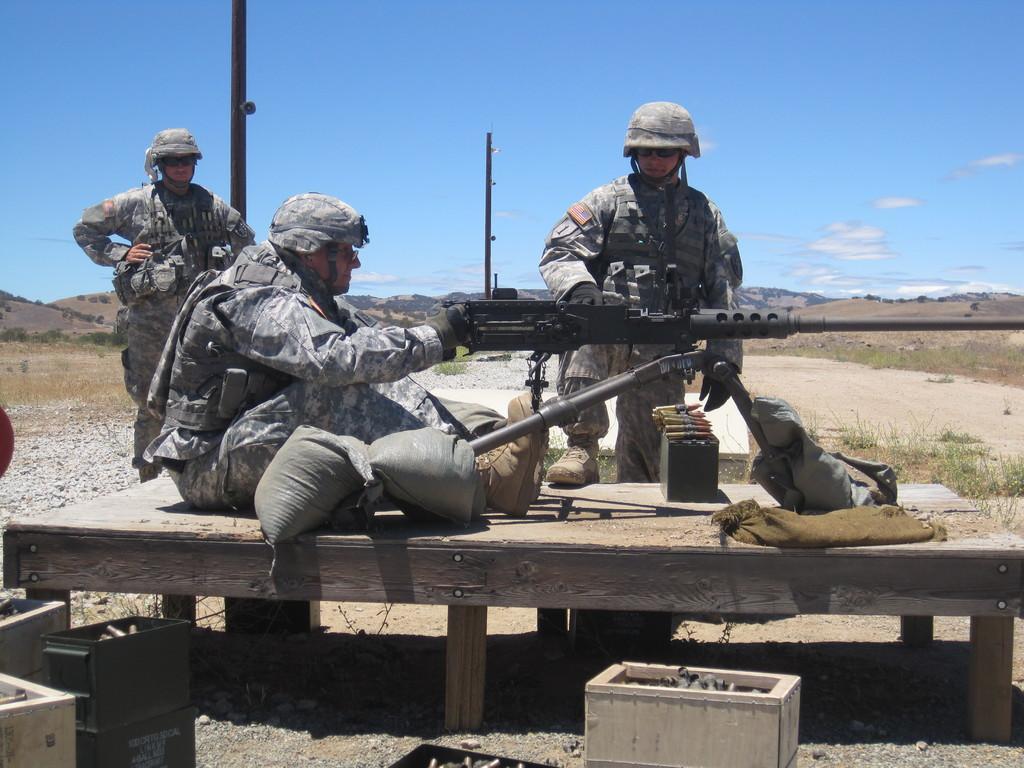Could you give a brief overview of what you see in this image? In this image we can see men standing and sitting on the ground and one of them is holding a rifle in the hands. In the background we can see bullets, cartons, grass, hills and sky with clouds. 